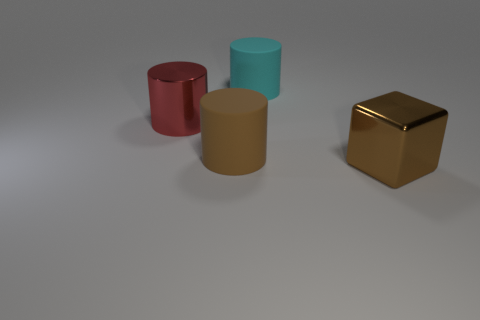What is the big object that is both in front of the red object and to the left of the big block made of?
Make the answer very short. Rubber. Are there fewer objects than small yellow spheres?
Provide a short and direct response. No. There is a metallic thing to the left of the object behind the large red object; what size is it?
Offer a very short reply. Large. What shape is the big matte object that is in front of the cylinder right of the brown object left of the large block?
Your answer should be compact. Cylinder. What is the color of the large object that is the same material as the cyan cylinder?
Offer a very short reply. Brown. There is a big metallic object that is in front of the rubber thing in front of the big metallic thing that is left of the brown shiny block; what color is it?
Offer a very short reply. Brown. How many spheres are tiny red things or large brown rubber things?
Your answer should be very brief. 0. What material is the big thing that is the same color as the block?
Your answer should be compact. Rubber. There is a big shiny cube; is it the same color as the big matte object that is in front of the big cyan thing?
Make the answer very short. Yes. The big metallic cylinder has what color?
Ensure brevity in your answer.  Red. 